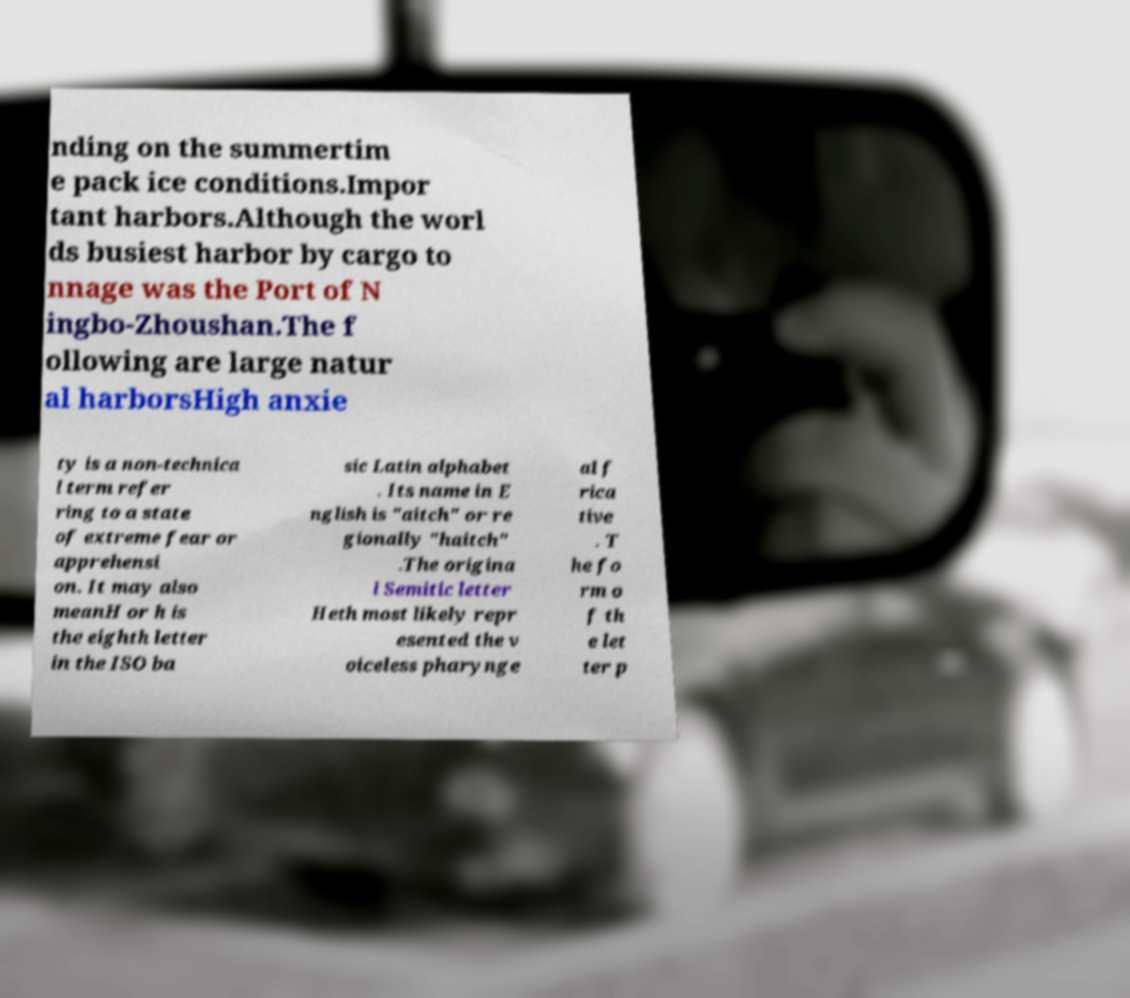Could you extract and type out the text from this image? nding on the summertim e pack ice conditions.Impor tant harbors.Although the worl ds busiest harbor by cargo to nnage was the Port of N ingbo-Zhoushan.The f ollowing are large natur al harborsHigh anxie ty is a non-technica l term refer ring to a state of extreme fear or apprehensi on. It may also meanH or h is the eighth letter in the ISO ba sic Latin alphabet . Its name in E nglish is "aitch" or re gionally "haitch" .The origina l Semitic letter Heth most likely repr esented the v oiceless pharynge al f rica tive . T he fo rm o f th e let ter p 